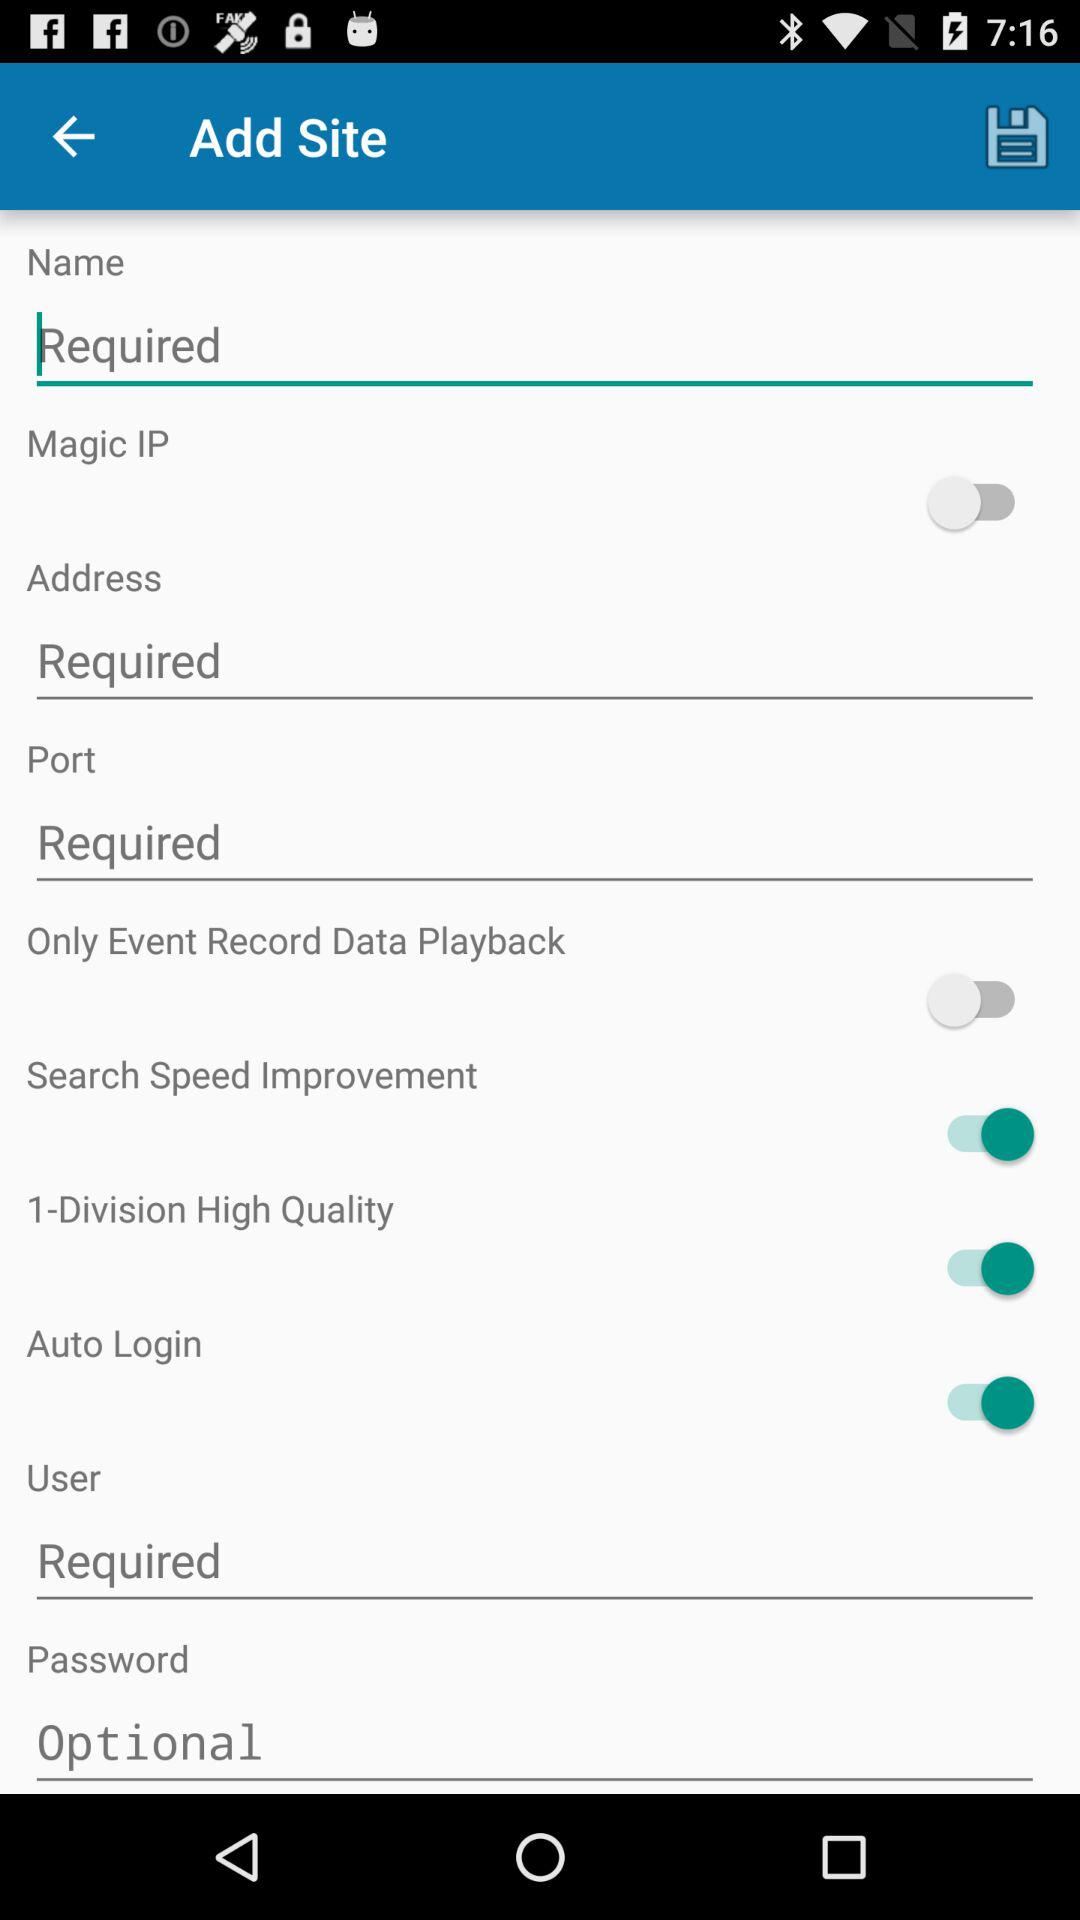What is the site name option? The site name option is "Magic IP". 